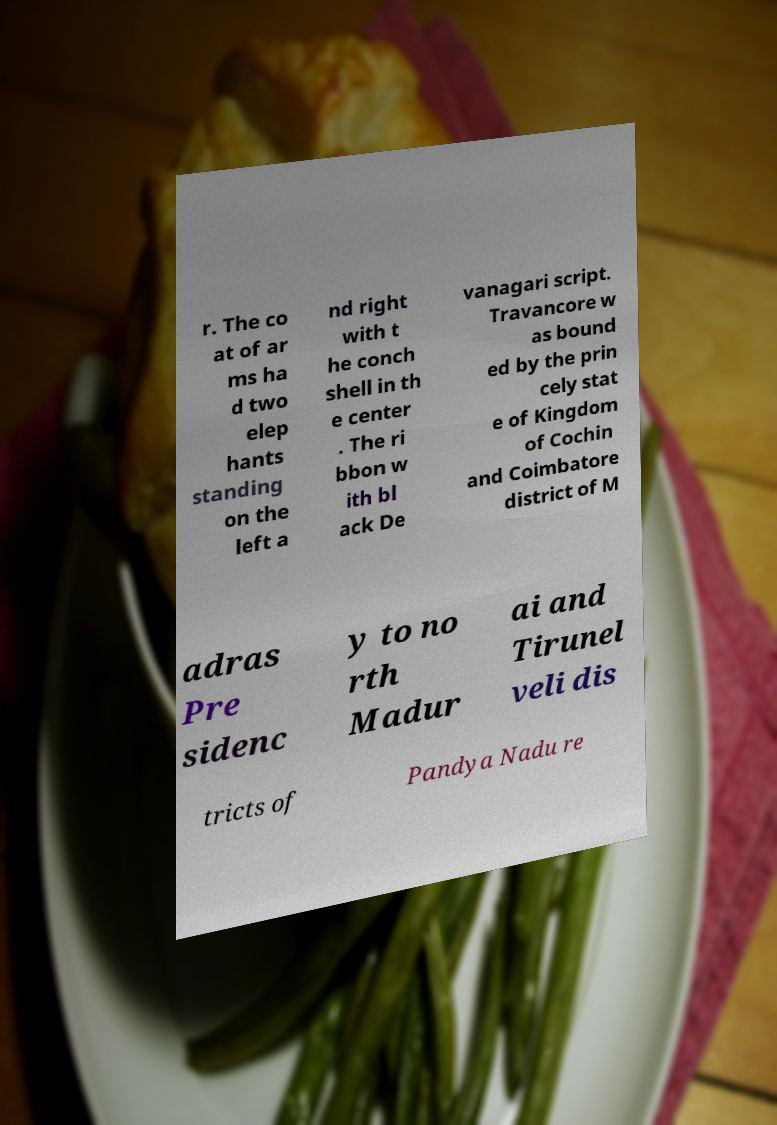What messages or text are displayed in this image? I need them in a readable, typed format. r. The co at of ar ms ha d two elep hants standing on the left a nd right with t he conch shell in th e center . The ri bbon w ith bl ack De vanagari script. Travancore w as bound ed by the prin cely stat e of Kingdom of Cochin and Coimbatore district of M adras Pre sidenc y to no rth Madur ai and Tirunel veli dis tricts of Pandya Nadu re 